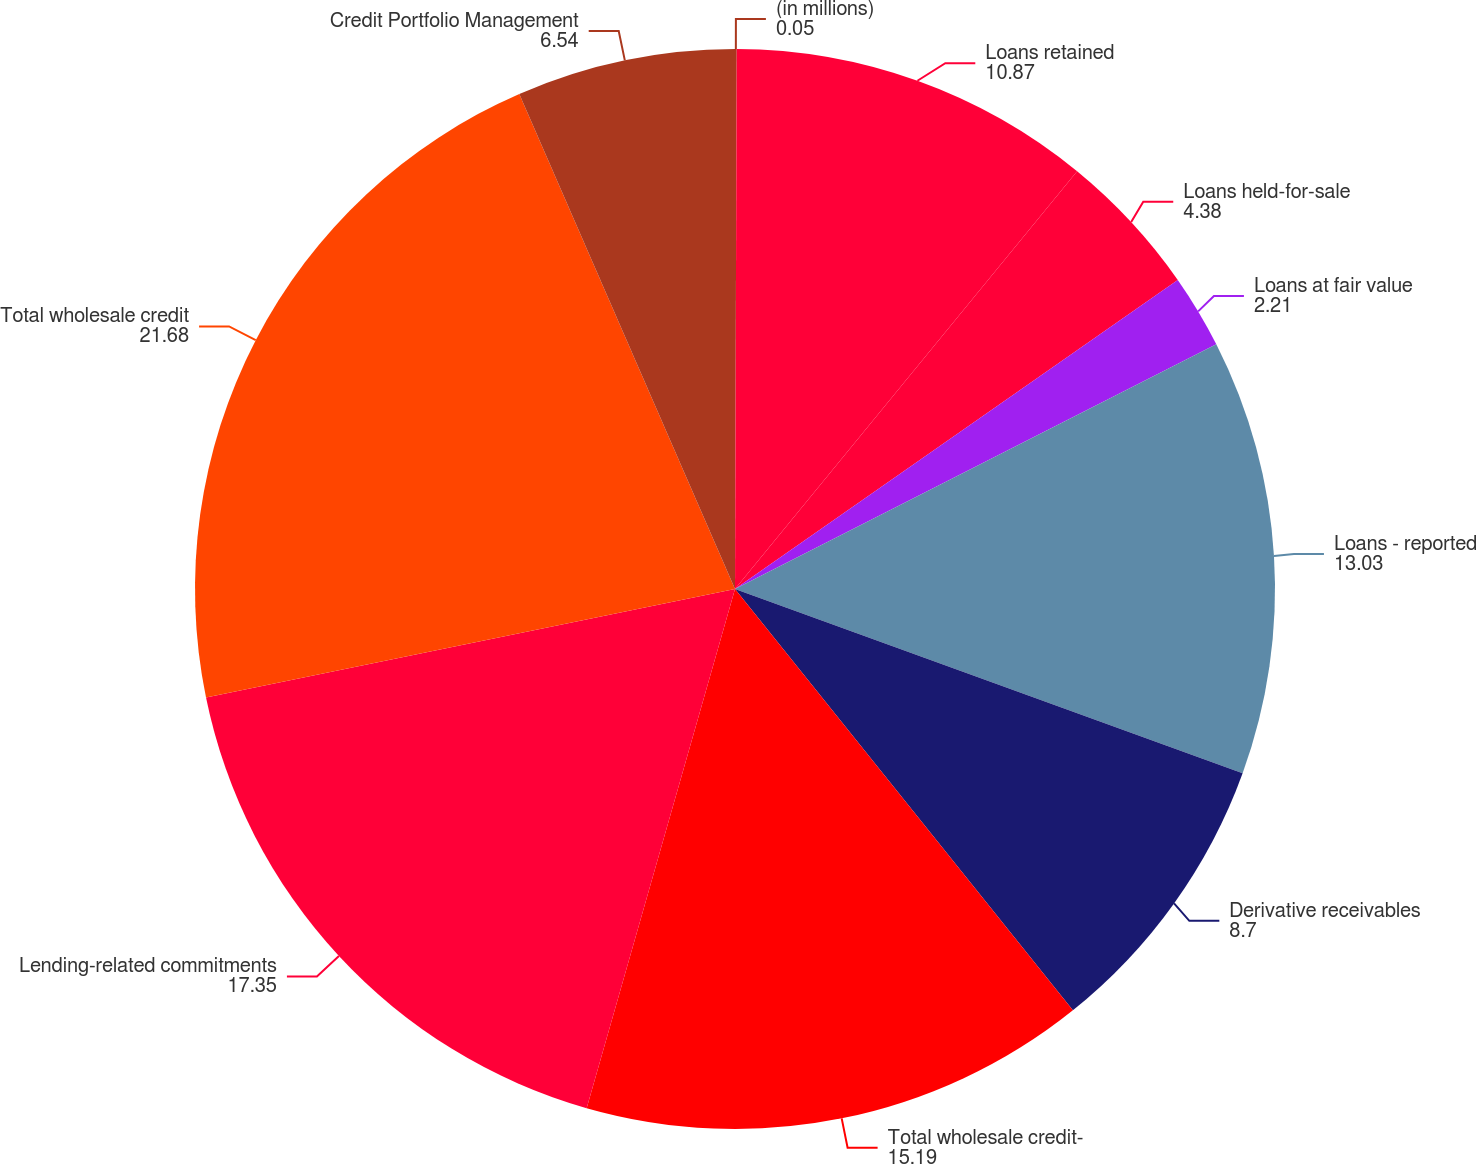Convert chart. <chart><loc_0><loc_0><loc_500><loc_500><pie_chart><fcel>(in millions)<fcel>Loans retained<fcel>Loans held-for-sale<fcel>Loans at fair value<fcel>Loans - reported<fcel>Derivative receivables<fcel>Total wholesale credit-<fcel>Lending-related commitments<fcel>Total wholesale credit<fcel>Credit Portfolio Management<nl><fcel>0.05%<fcel>10.87%<fcel>4.38%<fcel>2.21%<fcel>13.03%<fcel>8.7%<fcel>15.19%<fcel>17.35%<fcel>21.68%<fcel>6.54%<nl></chart> 